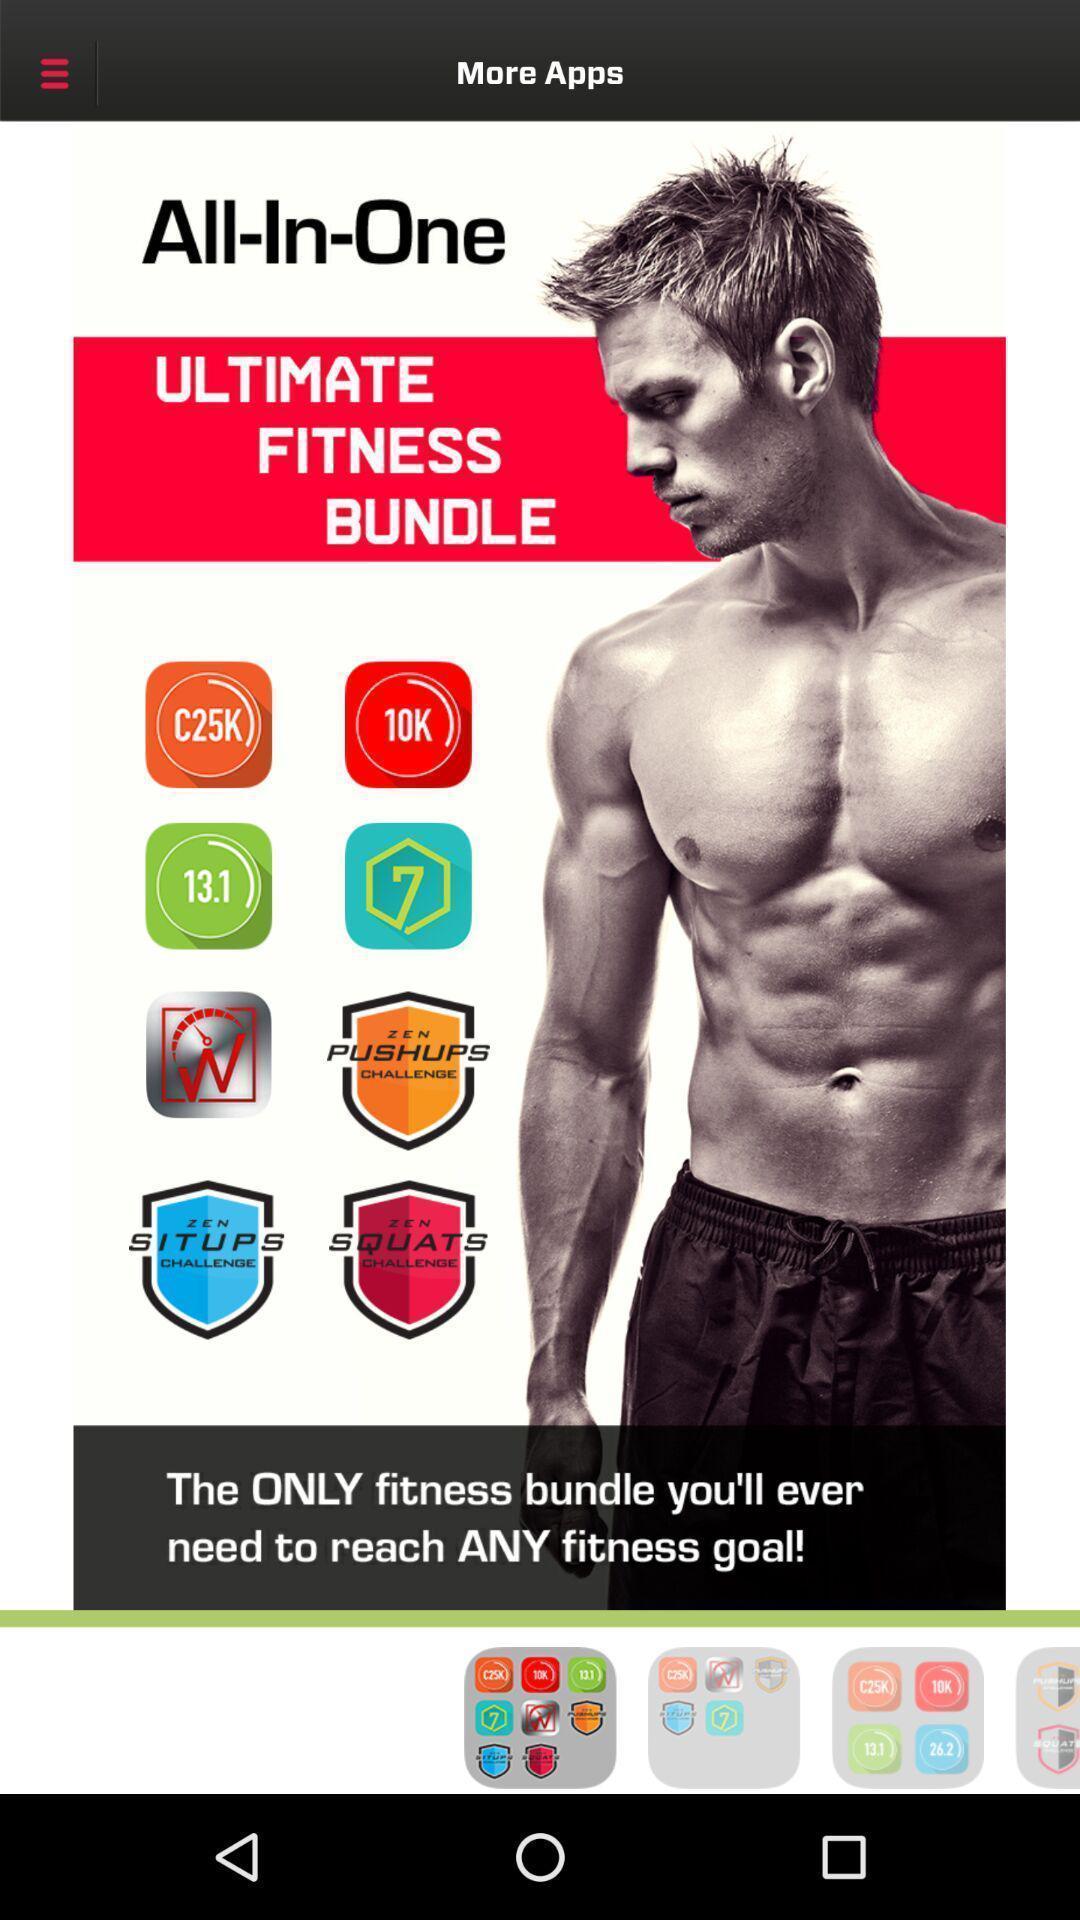Explain what's happening in this screen capture. Screen showing more apps. 